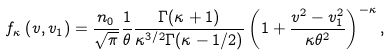Convert formula to latex. <formula><loc_0><loc_0><loc_500><loc_500>f _ { \kappa } \left ( v , v _ { 1 } \right ) = \frac { n _ { 0 } } { \sqrt { \pi } } \frac { 1 } { \theta } \frac { \Gamma ( \kappa + 1 ) } { \kappa ^ { 3 / 2 } \Gamma ( \kappa - 1 / 2 ) } \left ( 1 + \frac { v ^ { 2 } - v _ { 1 } ^ { 2 } } { \kappa \theta ^ { 2 } } \right ) ^ { - \kappa } ,</formula> 